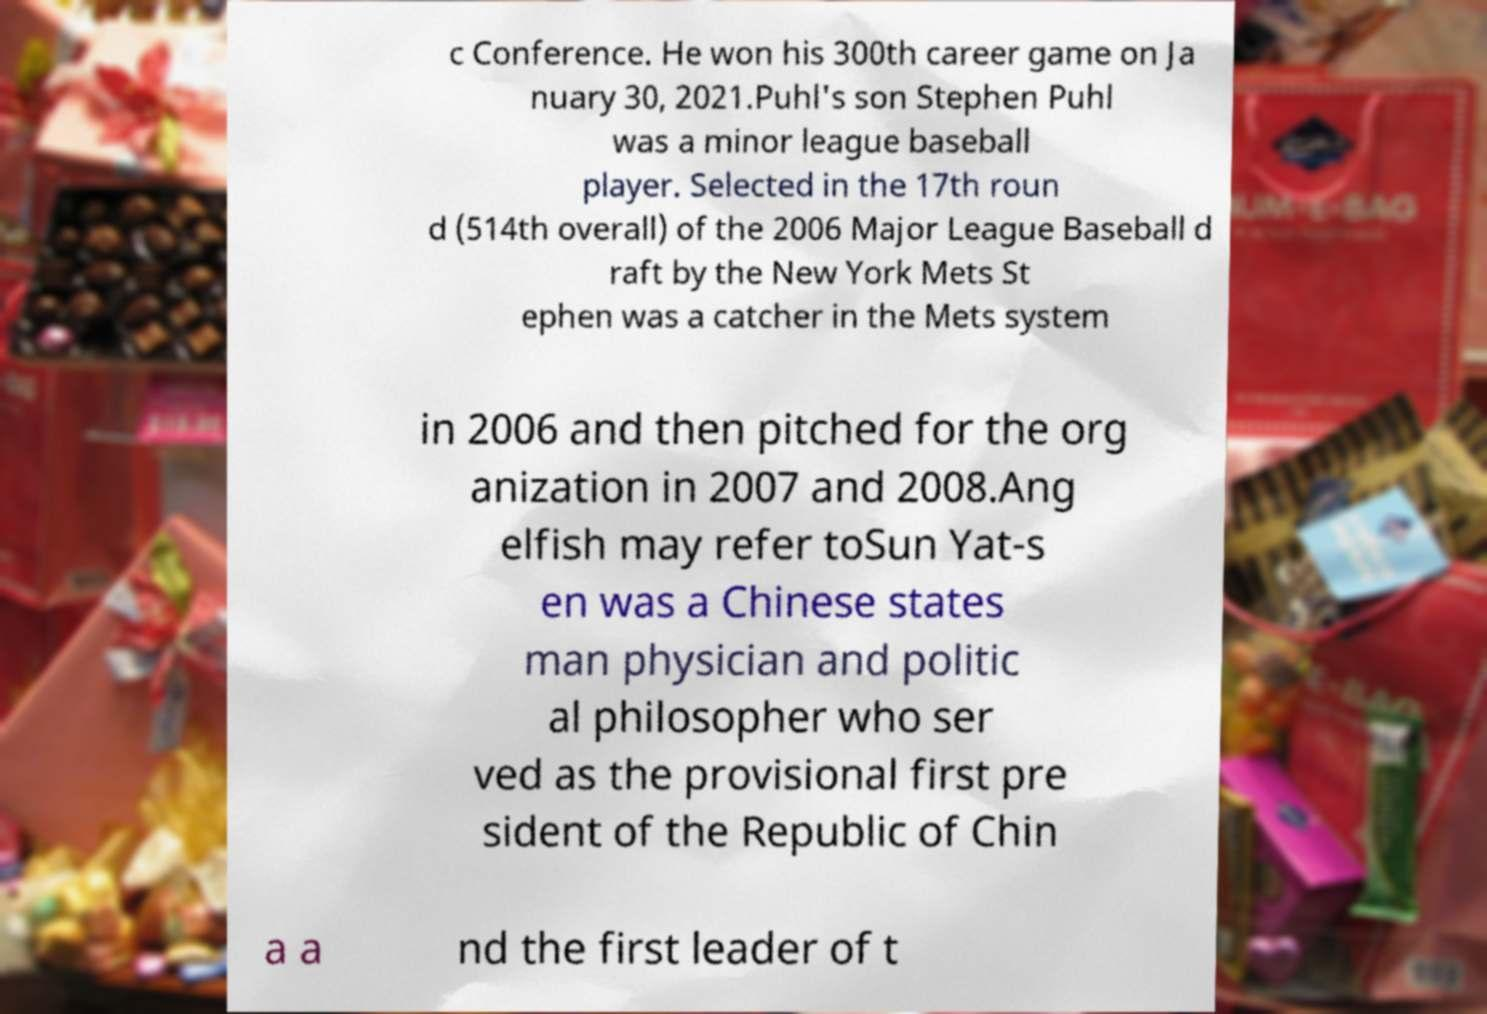There's text embedded in this image that I need extracted. Can you transcribe it verbatim? c Conference. He won his 300th career game on Ja nuary 30, 2021.Puhl's son Stephen Puhl was a minor league baseball player. Selected in the 17th roun d (514th overall) of the 2006 Major League Baseball d raft by the New York Mets St ephen was a catcher in the Mets system in 2006 and then pitched for the org anization in 2007 and 2008.Ang elfish may refer toSun Yat-s en was a Chinese states man physician and politic al philosopher who ser ved as the provisional first pre sident of the Republic of Chin a a nd the first leader of t 